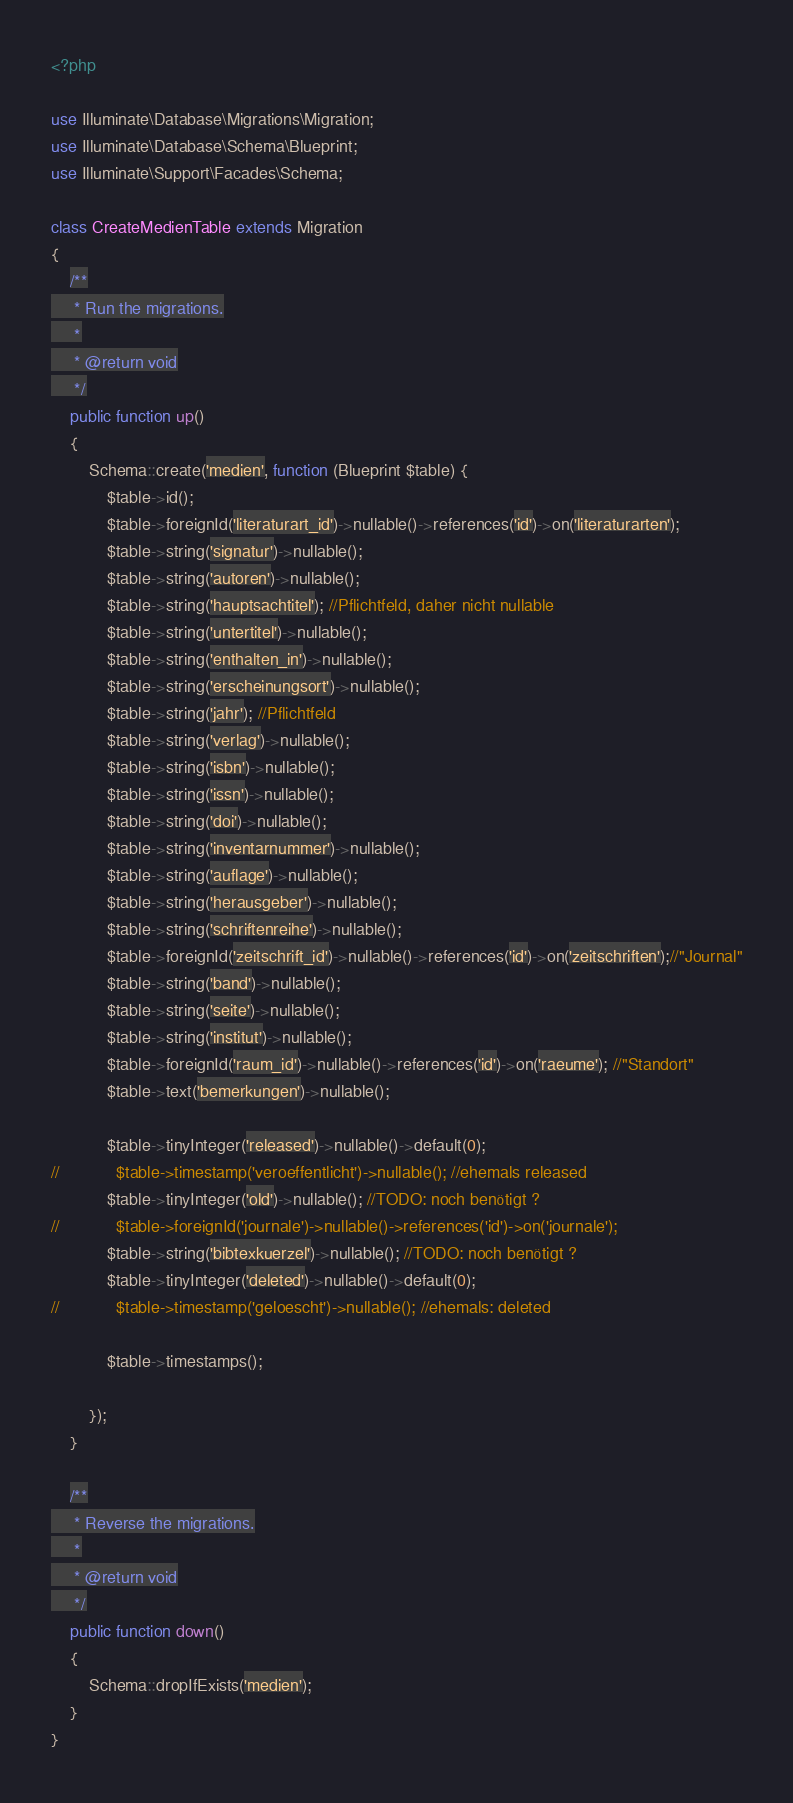Convert code to text. <code><loc_0><loc_0><loc_500><loc_500><_PHP_><?php

use Illuminate\Database\Migrations\Migration;
use Illuminate\Database\Schema\Blueprint;
use Illuminate\Support\Facades\Schema;

class CreateMedienTable extends Migration
{
    /**
     * Run the migrations.
     *
     * @return void
     */
    public function up()
    {
        Schema::create('medien', function (Blueprint $table) {
            $table->id();
            $table->foreignId('literaturart_id')->nullable()->references('id')->on('literaturarten');
            $table->string('signatur')->nullable();
            $table->string('autoren')->nullable();
            $table->string('hauptsachtitel'); //Pflichtfeld, daher nicht nullable
            $table->string('untertitel')->nullable();
            $table->string('enthalten_in')->nullable();
            $table->string('erscheinungsort')->nullable();
            $table->string('jahr'); //Pflichtfeld
            $table->string('verlag')->nullable();
            $table->string('isbn')->nullable();
            $table->string('issn')->nullable();
            $table->string('doi')->nullable();
            $table->string('inventarnummer')->nullable();
            $table->string('auflage')->nullable();
            $table->string('herausgeber')->nullable();
            $table->string('schriftenreihe')->nullable();
            $table->foreignId('zeitschrift_id')->nullable()->references('id')->on('zeitschriften');//"Journal"
            $table->string('band')->nullable();
            $table->string('seite')->nullable();
            $table->string('institut')->nullable();
            $table->foreignId('raum_id')->nullable()->references('id')->on('raeume'); //"Standort"
            $table->text('bemerkungen')->nullable();

            $table->tinyInteger('released')->nullable()->default(0);
//            $table->timestamp('veroeffentlicht')->nullable(); //ehemals released
            $table->tinyInteger('old')->nullable(); //TODO: noch benötigt ?
//            $table->foreignId('journale')->nullable()->references('id')->on('journale');
            $table->string('bibtexkuerzel')->nullable(); //TODO: noch benötigt ?
            $table->tinyInteger('deleted')->nullable()->default(0);
//            $table->timestamp('geloescht')->nullable(); //ehemals: deleted

            $table->timestamps();

        });
    }

    /**
     * Reverse the migrations.
     *
     * @return void
     */
    public function down()
    {
        Schema::dropIfExists('medien');
    }
}
</code> 